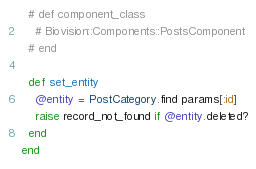Convert code to text. <code><loc_0><loc_0><loc_500><loc_500><_Ruby_>  # def component_class
    # Biovision::Components::PostsComponent
  # end

  def set_entity
    @entity = PostCategory.find params[:id]
    raise record_not_found if @entity.deleted?
  end
end
</code> 